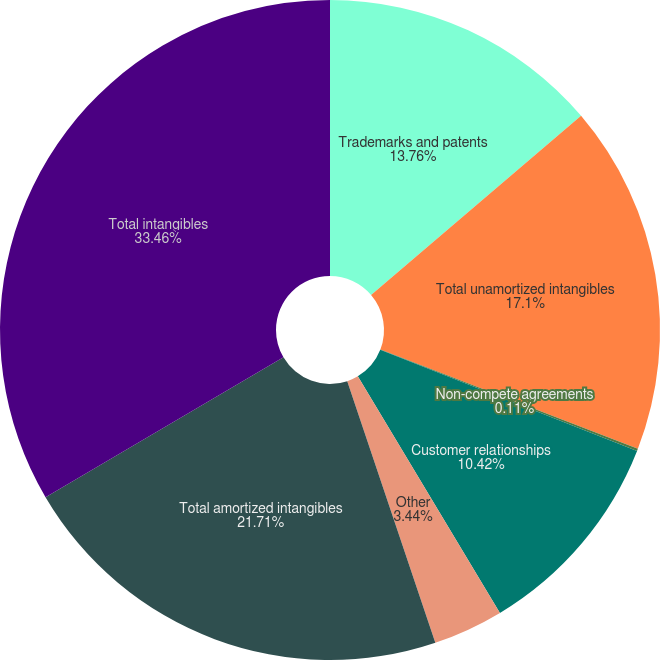Convert chart. <chart><loc_0><loc_0><loc_500><loc_500><pie_chart><fcel>Trademarks and patents<fcel>Total unamortized intangibles<fcel>Non-compete agreements<fcel>Customer relationships<fcel>Other<fcel>Total amortized intangibles<fcel>Total intangibles<nl><fcel>13.76%<fcel>17.1%<fcel>0.11%<fcel>10.42%<fcel>3.44%<fcel>21.71%<fcel>33.46%<nl></chart> 